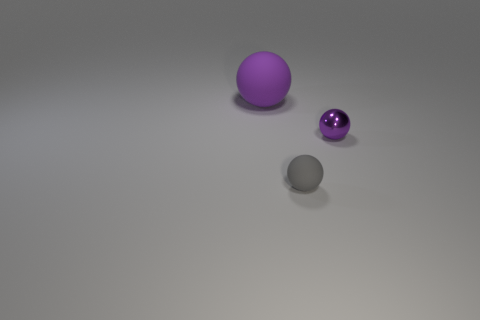Is the gray thing the same shape as the metallic object?
Keep it short and to the point. Yes. Is there any other thing that has the same material as the big thing?
Your answer should be very brief. Yes. Is the size of the thing that is on the right side of the small gray object the same as the rubber object that is to the left of the small rubber object?
Make the answer very short. No. There is a ball that is in front of the large purple ball and behind the gray matte ball; what material is it made of?
Your response must be concise. Metal. Are there any other things that are the same color as the metal sphere?
Provide a short and direct response. Yes. Is the number of tiny things behind the gray rubber thing less than the number of small purple shiny spheres?
Your answer should be compact. No. Is the number of large green spheres greater than the number of big purple rubber spheres?
Ensure brevity in your answer.  No. Are there any big purple rubber objects that are to the right of the thing left of the rubber object in front of the purple metal ball?
Ensure brevity in your answer.  No. How many other things are there of the same size as the purple matte object?
Your answer should be very brief. 0. Are there any small purple spheres in front of the tiny purple shiny sphere?
Provide a short and direct response. No. 